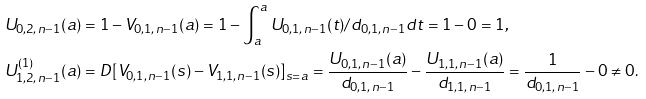Convert formula to latex. <formula><loc_0><loc_0><loc_500><loc_500>& U _ { 0 , 2 , n - 1 } ( a ) = 1 - V _ { 0 , 1 , n - 1 } ( a ) = 1 - \int _ { a } ^ { a } U _ { 0 , 1 , n - 1 } ( t ) / d _ { 0 , 1 , n - 1 } d t = 1 - 0 = 1 , \\ & U _ { 1 , 2 , n - 1 } ^ { ( 1 ) } ( a ) = D [ V _ { 0 , 1 , n - 1 } ( s ) - V _ { 1 , 1 , n - 1 } ( s ) ] _ { s = a } = \frac { U _ { 0 , 1 , n - 1 } ( a ) } { d _ { 0 , 1 , n - 1 } } - \frac { U _ { 1 , 1 , n - 1 } ( a ) } { d _ { 1 , 1 , n - 1 } } = \frac { 1 } { d _ { 0 , 1 , n - 1 } } - 0 \neq 0 . \\</formula> 